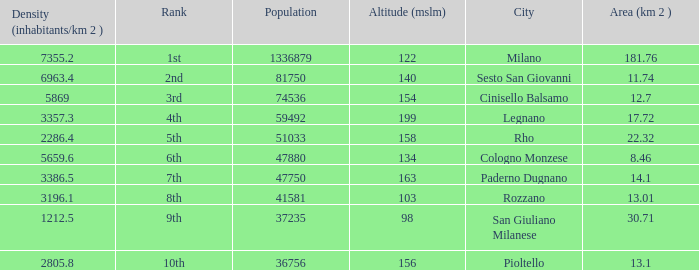Which Altitude (mslm) is the highest one that has an Area (km 2) smaller than 13.01, and a Population of 74536, and a Density (inhabitants/km 2) larger than 5869? None. 